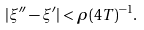<formula> <loc_0><loc_0><loc_500><loc_500>| \xi ^ { \prime \prime } - \xi ^ { \prime } | < \rho ( 4 T ) ^ { - 1 } .</formula> 